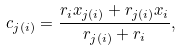Convert formula to latex. <formula><loc_0><loc_0><loc_500><loc_500>c _ { j ( i ) } = \frac { r _ { i } x _ { j ( i ) } + r _ { j ( i ) } x _ { i } } { r _ { j ( i ) } + r _ { i } } ,</formula> 